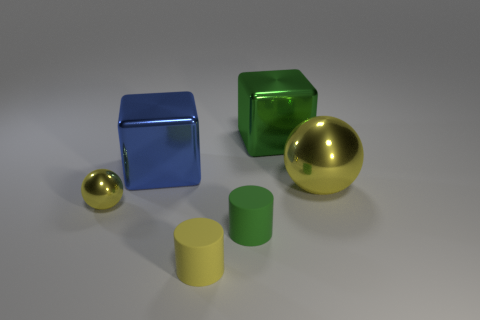There is a yellow object that is the same shape as the tiny green rubber thing; what is it made of?
Provide a short and direct response. Rubber. There is a sphere that is behind the ball that is in front of the big sphere to the right of the tiny yellow shiny sphere; what color is it?
Your response must be concise. Yellow. How many objects are large things or blue cubes?
Your answer should be compact. 3. What number of other yellow metallic things are the same shape as the big yellow object?
Your answer should be compact. 1. Does the green cylinder have the same material as the tiny yellow object on the right side of the big blue cube?
Provide a succinct answer. Yes. There is another cube that is the same material as the large green block; what is its size?
Ensure brevity in your answer.  Large. There is a yellow metal ball that is to the right of the tiny shiny thing; what is its size?
Offer a terse response. Large. How many yellow shiny balls have the same size as the green matte cylinder?
Your answer should be very brief. 1. What is the size of the shiny thing that is the same color as the tiny metallic sphere?
Ensure brevity in your answer.  Large. Is there another object of the same color as the small metal thing?
Make the answer very short. Yes. 